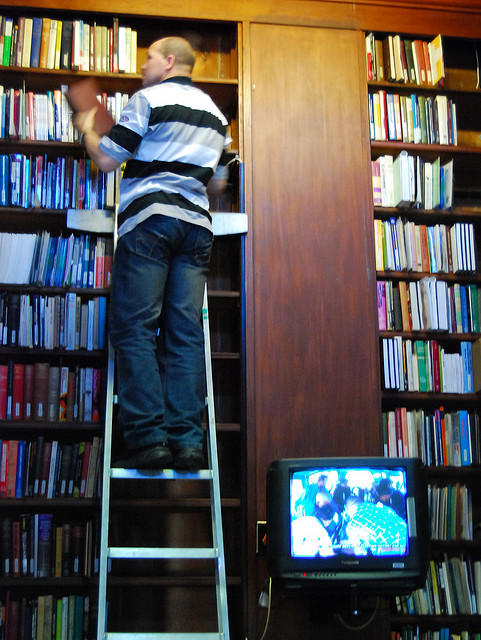What challenges might visitors face in this library? Visitors to this library may encounter difficulties when trying to access books on higher shelves. In the provided image, we see an individual on a ladder reaching for a book placed on a top shelf, highlighting the need for additional tools to access such areas. Ensuring accessibility for all, including those who may be short or have disabilities, is crucial. The library could enhance user experience by either reorganizing the books to make frequently used resources more reachable, or by introducing easily accessible tools like mobile staircases or adjustable shelving. 